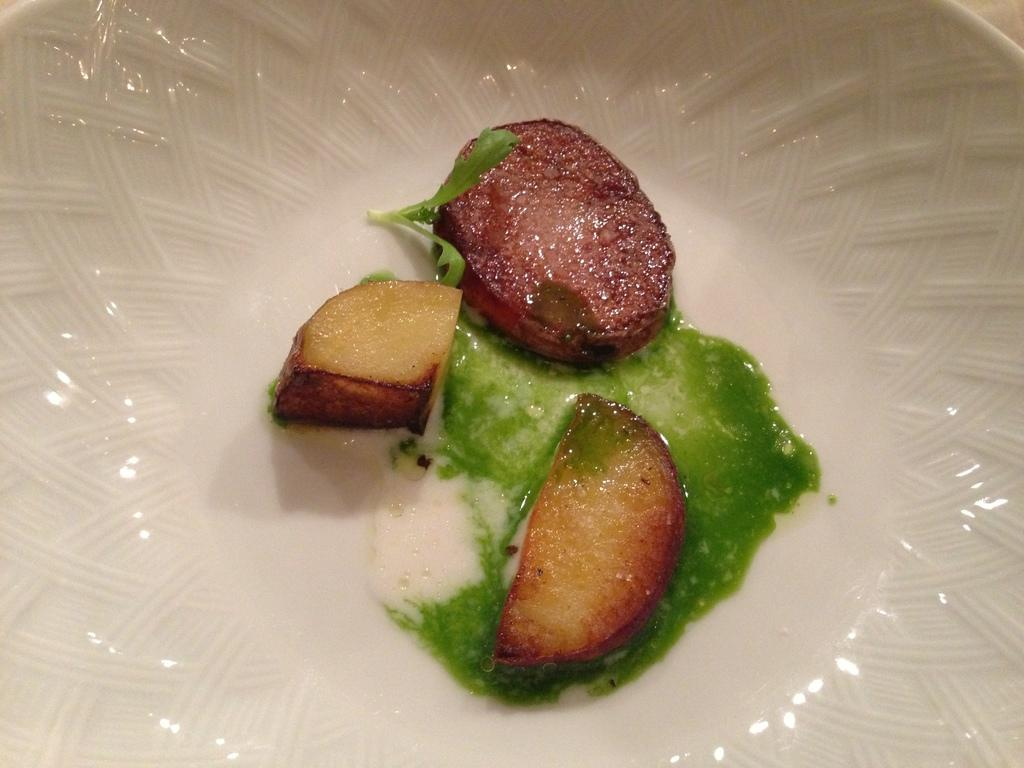What type of food can be seen in the image? There are meat pieces in the image. What condiment is present with the meat pieces? There is chili sauce in the image. Where are the meat pieces and chili sauce located? The meat pieces and chili sauce are in a bowl. On what surface is the bowl placed? The bowl is on a table. What time of day is depicted in the image? The image does not show any indication of the time of day, so it cannot be determined. What type of soup can be seen in the image? There is no soup present in the image; it features meat pieces and chili sauce in a bowl. 